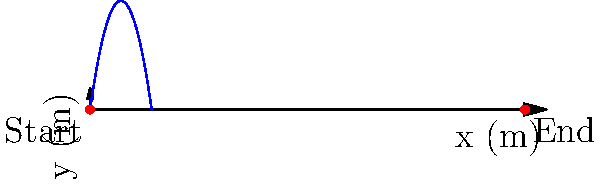In a new board game you're reviewing, players launch a small ball from a spring-loaded device. If the ball is launched with an initial velocity of 10 m/s at a 45-degree angle, what is the maximum height reached by the ball during its trajectory? (Assume g = 9.8 m/s^2 and neglect air resistance) To find the maximum height of the ball's trajectory, we can follow these steps:

1. Identify the given information:
   - Initial velocity, $v_0 = 10$ m/s
   - Launch angle, $\theta = 45°$ (or $\pi/4$ radians)
   - Acceleration due to gravity, $g = 9.8$ m/s^2

2. The maximum height occurs when the vertical velocity component is zero. We can use the equation:
   $y_{max} = \frac{v_0^2 \sin^2 \theta}{2g}$

3. Substitute the values:
   $y_{max} = \frac{(10 \text{ m/s})^2 \sin^2 (45°)}{2(9.8 \text{ m/s}^2)}$

4. Simplify:
   $y_{max} = \frac{100 \text{ m}^2/\text{s}^2 \cdot 0.5}{19.6 \text{ m/s}^2}$
   $y_{max} = \frac{50 \text{ m}^2/\text{s}^2}{19.6 \text{ m/s}^2}$

5. Calculate the final result:
   $y_{max} \approx 2.55$ m

Therefore, the maximum height reached by the ball is approximately 2.55 meters.
Answer: 2.55 m 